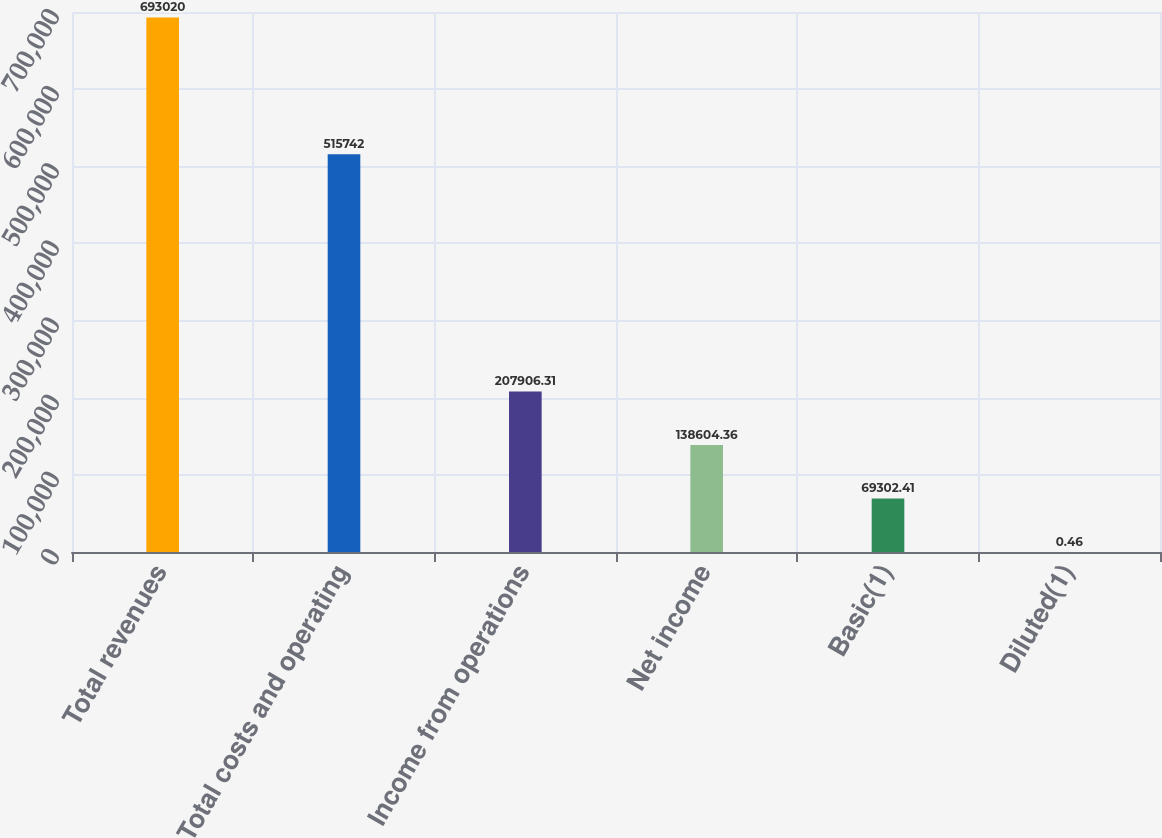Convert chart. <chart><loc_0><loc_0><loc_500><loc_500><bar_chart><fcel>Total revenues<fcel>Total costs and operating<fcel>Income from operations<fcel>Net income<fcel>Basic(1)<fcel>Diluted(1)<nl><fcel>693020<fcel>515742<fcel>207906<fcel>138604<fcel>69302.4<fcel>0.46<nl></chart> 